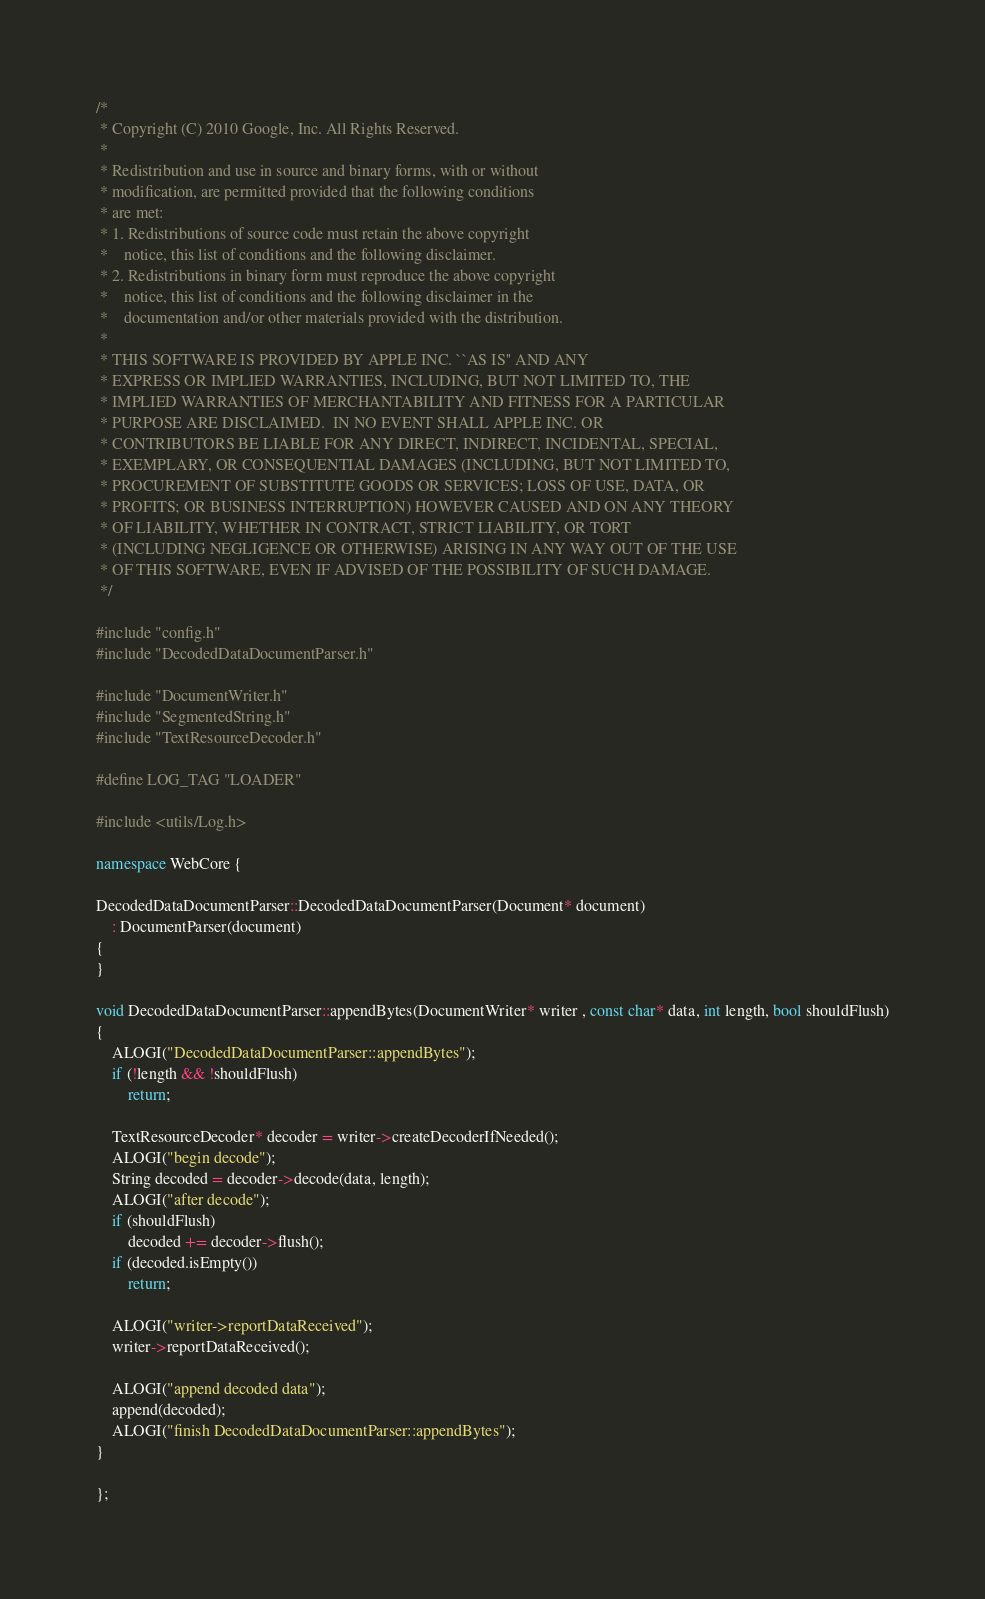<code> <loc_0><loc_0><loc_500><loc_500><_C++_>/*
 * Copyright (C) 2010 Google, Inc. All Rights Reserved.
 *
 * Redistribution and use in source and binary forms, with or without
 * modification, are permitted provided that the following conditions
 * are met:
 * 1. Redistributions of source code must retain the above copyright
 *    notice, this list of conditions and the following disclaimer.
 * 2. Redistributions in binary form must reproduce the above copyright
 *    notice, this list of conditions and the following disclaimer in the
 *    documentation and/or other materials provided with the distribution.
 *
 * THIS SOFTWARE IS PROVIDED BY APPLE INC. ``AS IS'' AND ANY
 * EXPRESS OR IMPLIED WARRANTIES, INCLUDING, BUT NOT LIMITED TO, THE
 * IMPLIED WARRANTIES OF MERCHANTABILITY AND FITNESS FOR A PARTICULAR
 * PURPOSE ARE DISCLAIMED.  IN NO EVENT SHALL APPLE INC. OR
 * CONTRIBUTORS BE LIABLE FOR ANY DIRECT, INDIRECT, INCIDENTAL, SPECIAL,
 * EXEMPLARY, OR CONSEQUENTIAL DAMAGES (INCLUDING, BUT NOT LIMITED TO,
 * PROCUREMENT OF SUBSTITUTE GOODS OR SERVICES; LOSS OF USE, DATA, OR
 * PROFITS; OR BUSINESS INTERRUPTION) HOWEVER CAUSED AND ON ANY THEORY
 * OF LIABILITY, WHETHER IN CONTRACT, STRICT LIABILITY, OR TORT
 * (INCLUDING NEGLIGENCE OR OTHERWISE) ARISING IN ANY WAY OUT OF THE USE
 * OF THIS SOFTWARE, EVEN IF ADVISED OF THE POSSIBILITY OF SUCH DAMAGE.
 */

#include "config.h"
#include "DecodedDataDocumentParser.h"

#include "DocumentWriter.h"
#include "SegmentedString.h"
#include "TextResourceDecoder.h"

#define LOG_TAG "LOADER"

#include <utils/Log.h>

namespace WebCore {

DecodedDataDocumentParser::DecodedDataDocumentParser(Document* document)
    : DocumentParser(document)
{
}

void DecodedDataDocumentParser::appendBytes(DocumentWriter* writer , const char* data, int length, bool shouldFlush)
{
    ALOGI("DecodedDataDocumentParser::appendBytes");
    if (!length && !shouldFlush)
        return;

    TextResourceDecoder* decoder = writer->createDecoderIfNeeded();
    ALOGI("begin decode");
    String decoded = decoder->decode(data, length);
    ALOGI("after decode");
    if (shouldFlush)
        decoded += decoder->flush();
    if (decoded.isEmpty())
        return;

    ALOGI("writer->reportDataReceived");
    writer->reportDataReceived();

    ALOGI("append decoded data");
    append(decoded);
    ALOGI("finish DecodedDataDocumentParser::appendBytes");
}

};

</code> 